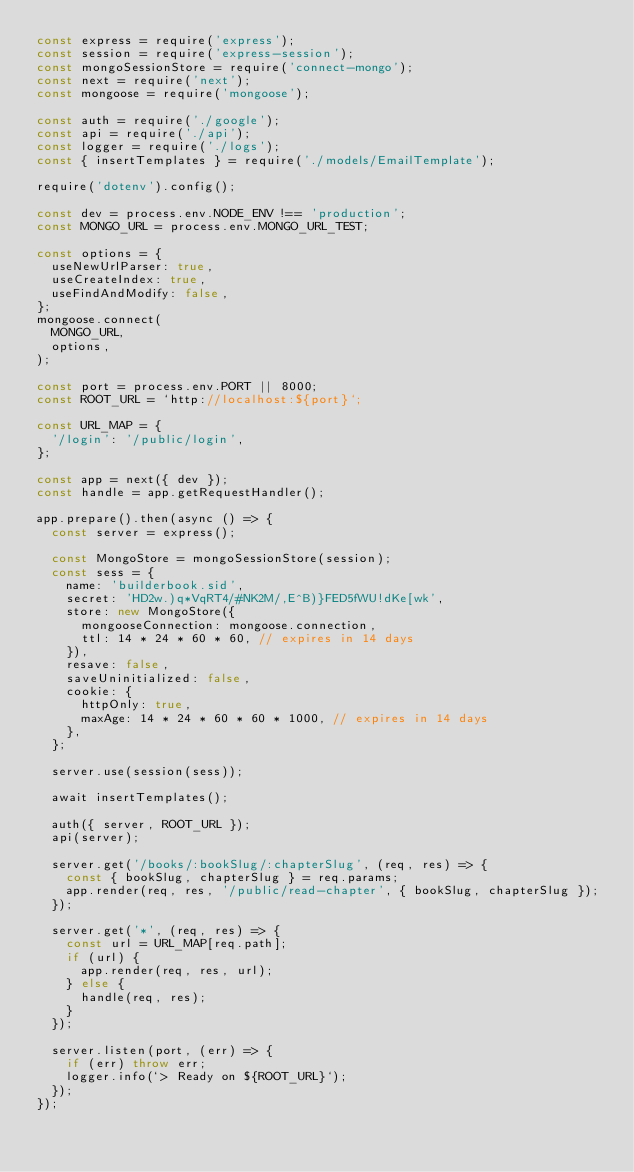Convert code to text. <code><loc_0><loc_0><loc_500><loc_500><_JavaScript_>const express = require('express');
const session = require('express-session');
const mongoSessionStore = require('connect-mongo');
const next = require('next');
const mongoose = require('mongoose');

const auth = require('./google');
const api = require('./api');
const logger = require('./logs');
const { insertTemplates } = require('./models/EmailTemplate');

require('dotenv').config();

const dev = process.env.NODE_ENV !== 'production';
const MONGO_URL = process.env.MONGO_URL_TEST;

const options = {
  useNewUrlParser: true,
  useCreateIndex: true,
  useFindAndModify: false,
};
mongoose.connect(
  MONGO_URL,
  options,
);

const port = process.env.PORT || 8000;
const ROOT_URL = `http://localhost:${port}`;

const URL_MAP = {
  '/login': '/public/login',
};

const app = next({ dev });
const handle = app.getRequestHandler();

app.prepare().then(async () => {
  const server = express();

  const MongoStore = mongoSessionStore(session);
  const sess = {
    name: 'builderbook.sid',
    secret: 'HD2w.)q*VqRT4/#NK2M/,E^B)}FED5fWU!dKe[wk',
    store: new MongoStore({
      mongooseConnection: mongoose.connection,
      ttl: 14 * 24 * 60 * 60, // expires in 14 days
    }),
    resave: false,
    saveUninitialized: false,
    cookie: {
      httpOnly: true,
      maxAge: 14 * 24 * 60 * 60 * 1000, // expires in 14 days
    },
  };

  server.use(session(sess));

  await insertTemplates();

  auth({ server, ROOT_URL });
  api(server);

  server.get('/books/:bookSlug/:chapterSlug', (req, res) => {
    const { bookSlug, chapterSlug } = req.params;
    app.render(req, res, '/public/read-chapter', { bookSlug, chapterSlug });
  });

  server.get('*', (req, res) => {
    const url = URL_MAP[req.path];
    if (url) {
      app.render(req, res, url);
    } else {
      handle(req, res);
    }
  });

  server.listen(port, (err) => {
    if (err) throw err;
    logger.info(`> Ready on ${ROOT_URL}`);
  });
});

</code> 